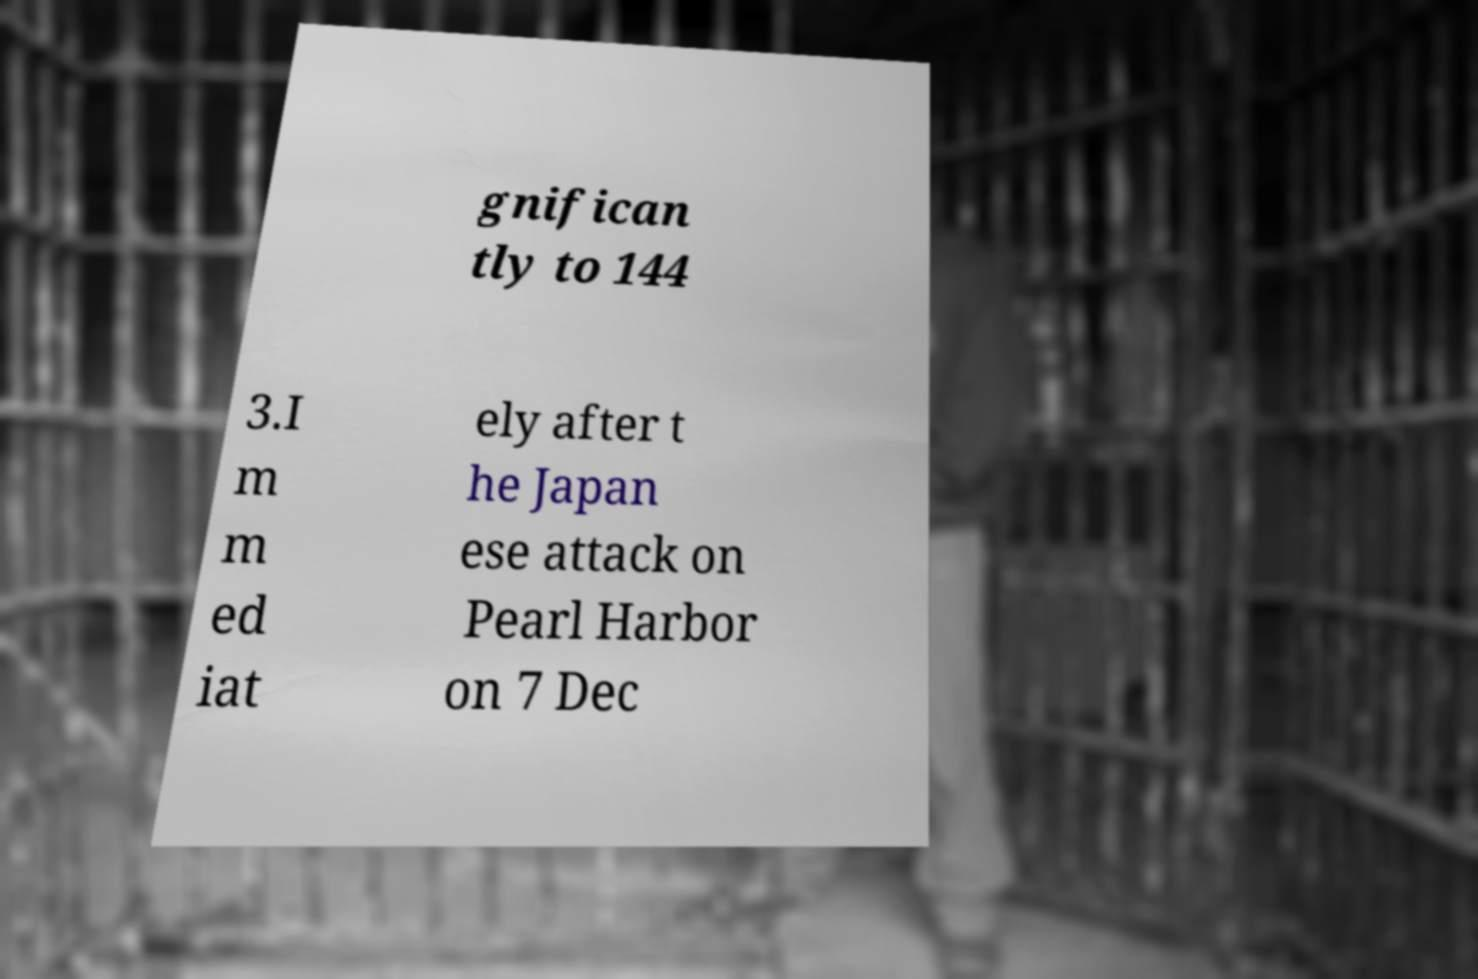Could you assist in decoding the text presented in this image and type it out clearly? gnifican tly to 144 3.I m m ed iat ely after t he Japan ese attack on Pearl Harbor on 7 Dec 